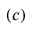<formula> <loc_0><loc_0><loc_500><loc_500>( c )</formula> 